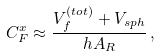<formula> <loc_0><loc_0><loc_500><loc_500>C _ { F } ^ { x } \approx \frac { V _ { f } ^ { ( t o t ) } + V _ { s p h } } { h A _ { R } } \, ,</formula> 